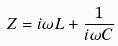Convert formula to latex. <formula><loc_0><loc_0><loc_500><loc_500>Z = i \omega L + \frac { 1 } { i \omega C }</formula> 